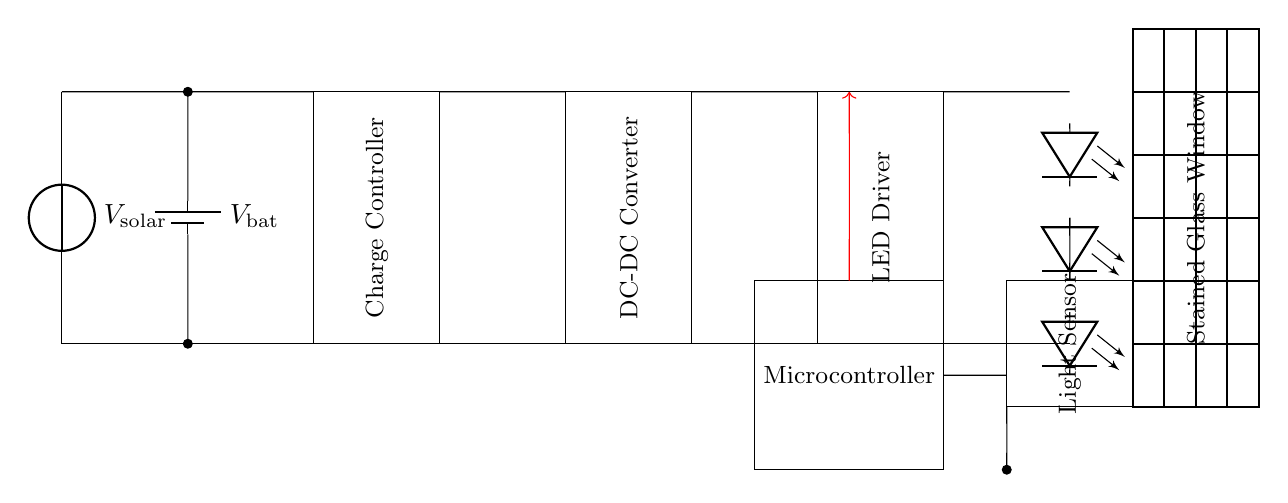What is the power source for this circuit? The power source is the solar panel depicted at the left side of the diagram, which generates voltage when exposed to sunlight.
Answer: Solar panel What component stores energy in this circuit? The component that stores energy is the battery, located next to the solar panel, which charges from the solar panel and supplies power when needed.
Answer: Battery What is the function of the charge controller? The charge controller manages the power coming from the solar panel to prevent overcharging of the battery and ensures efficient energy flow to the rest of the circuit.
Answer: To manage power How does the microcontroller interact with the LED driver? The microcontroller sends control signals to the LED driver, indicated by the red arrow pointing from the microcontroller to the LED driver, which allows automated control of the LED lights based on sensor inputs.
Answer: Sends control signals What type of light does this circuit illuminate? This circuit is designed to illuminate colored or decorative lights through the LED strips, which enhance the aesthetic of the stained glass window.
Answer: LED strips Which component detects light levels in the circuit? The light sensor is responsible for detecting ambient light levels, and its position in the diagram indicates it samples the environment to provide data to the microcontroller.
Answer: Light sensor 